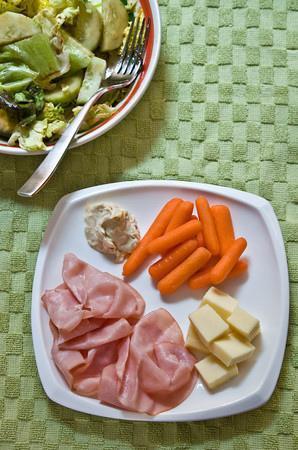How many plates are there?
Give a very brief answer. 2. How many carrots can you see?
Give a very brief answer. 1. How many dining tables are visible?
Give a very brief answer. 1. 